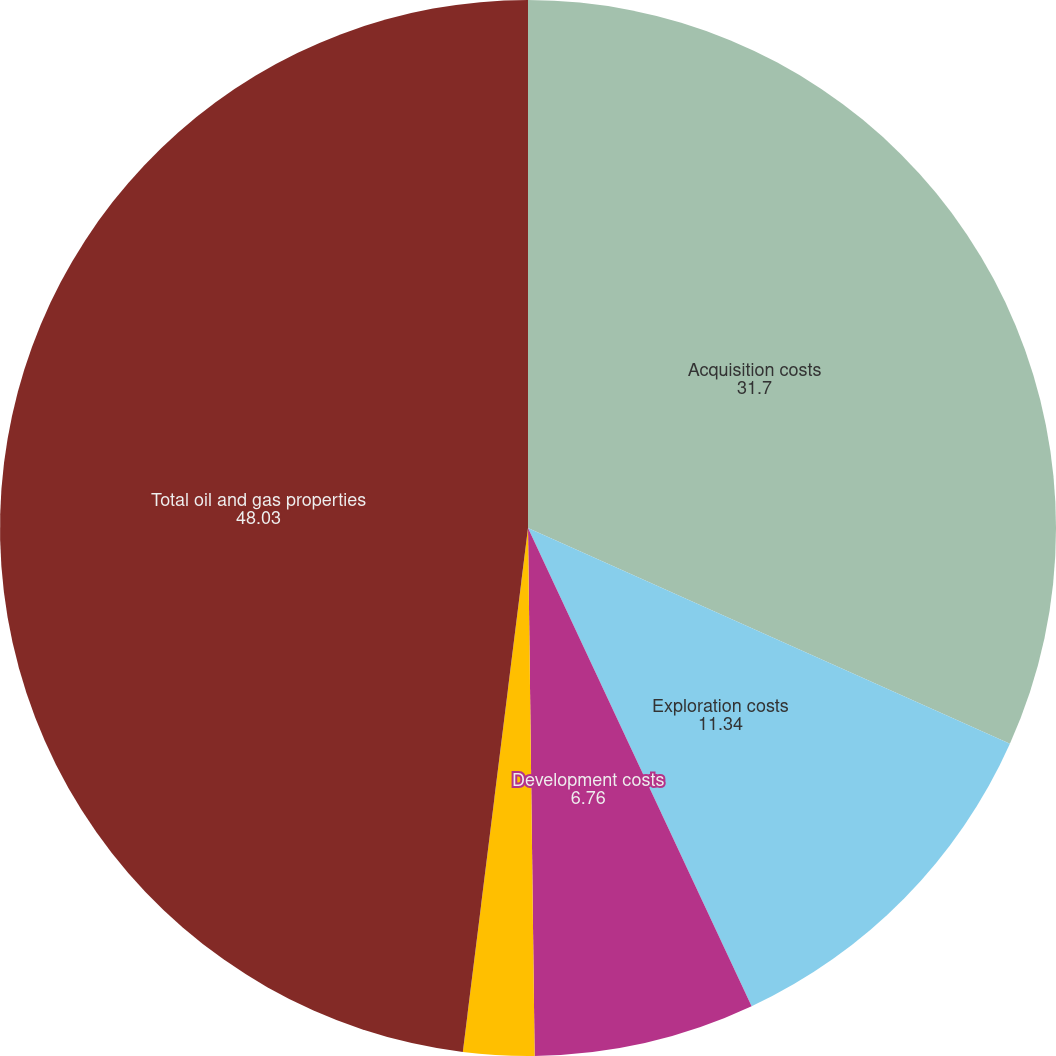Convert chart. <chart><loc_0><loc_0><loc_500><loc_500><pie_chart><fcel>Acquisition costs<fcel>Exploration costs<fcel>Development costs<fcel>Capitalized interest<fcel>Total oil and gas properties<nl><fcel>31.7%<fcel>11.34%<fcel>6.76%<fcel>2.17%<fcel>48.03%<nl></chart> 